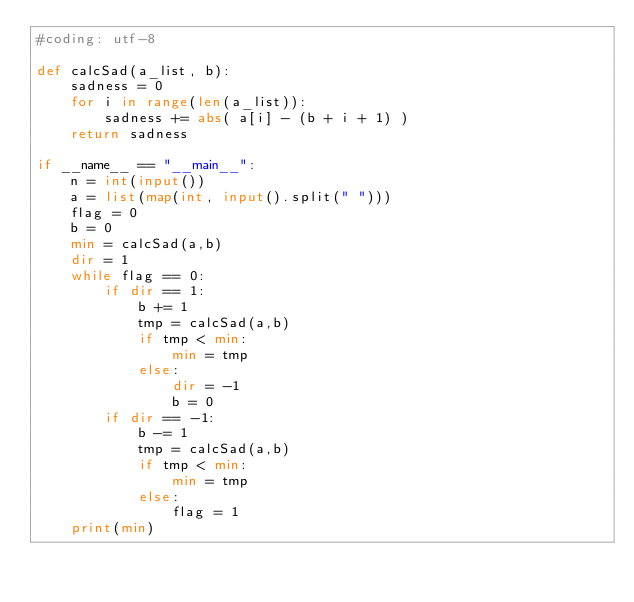<code> <loc_0><loc_0><loc_500><loc_500><_Python_>#coding: utf-8

def calcSad(a_list, b):
    sadness = 0
    for i in range(len(a_list)):
        sadness += abs( a[i] - (b + i + 1) )
    return sadness

if __name__ == "__main__":
    n = int(input())
    a = list(map(int, input().split(" ")))
    flag = 0
    b = 0
    min = calcSad(a,b)
    dir = 1
    while flag == 0:
        if dir == 1:
            b += 1
            tmp = calcSad(a,b)
            if tmp < min:
                min = tmp
            else:
                dir = -1
                b = 0
        if dir == -1:
            b -= 1
            tmp = calcSad(a,b)
            if tmp < min:
                min = tmp
            else:
                flag = 1
    print(min)
</code> 